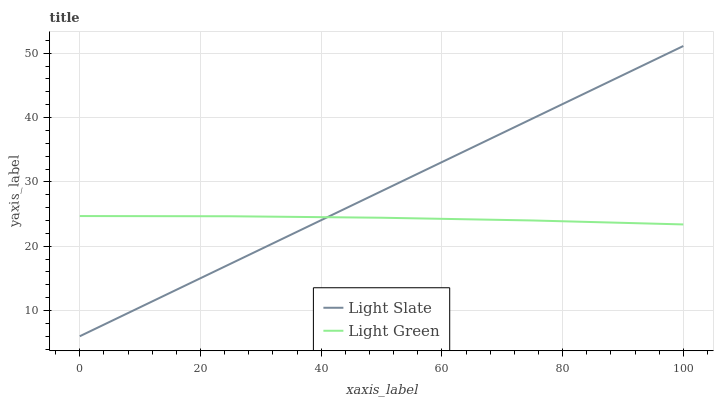Does Light Green have the minimum area under the curve?
Answer yes or no. Yes. Does Light Slate have the maximum area under the curve?
Answer yes or no. Yes. Does Light Green have the maximum area under the curve?
Answer yes or no. No. Is Light Slate the smoothest?
Answer yes or no. Yes. Is Light Green the roughest?
Answer yes or no. Yes. Is Light Green the smoothest?
Answer yes or no. No. Does Light Green have the lowest value?
Answer yes or no. No. Does Light Green have the highest value?
Answer yes or no. No. 